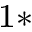Convert formula to latex. <formula><loc_0><loc_0><loc_500><loc_500>^ { 1 \ast }</formula> 